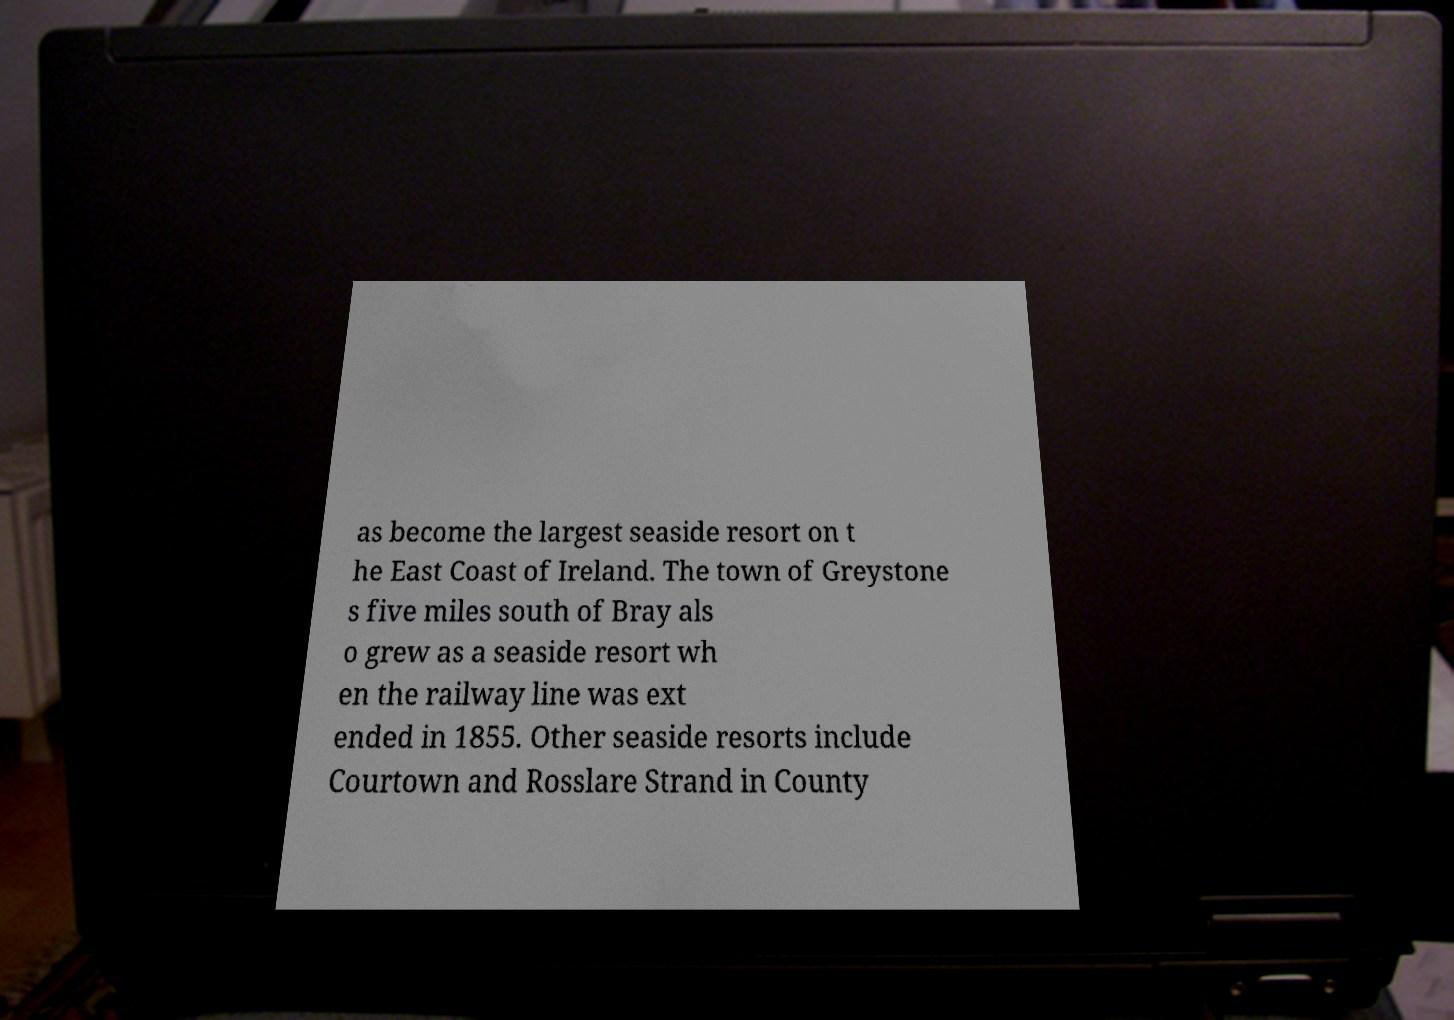Can you accurately transcribe the text from the provided image for me? as become the largest seaside resort on t he East Coast of Ireland. The town of Greystone s five miles south of Bray als o grew as a seaside resort wh en the railway line was ext ended in 1855. Other seaside resorts include Courtown and Rosslare Strand in County 